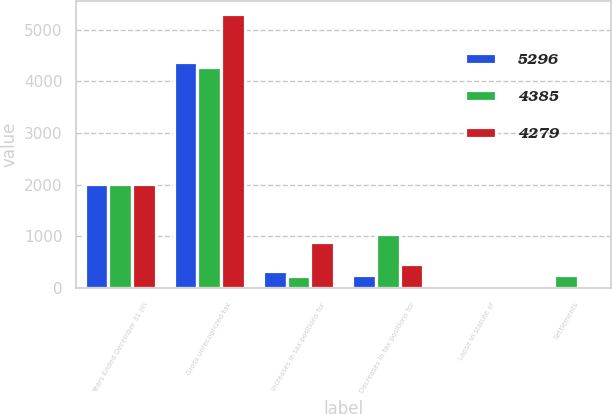Convert chart to OTSL. <chart><loc_0><loc_0><loc_500><loc_500><stacked_bar_chart><ecel><fcel>Years Ended December 31 (in<fcel>Gross unrecognized tax<fcel>Increases in tax positions for<fcel>Decreases in tax positions for<fcel>Lapse in statute of<fcel>Settlements<nl><fcel>5296<fcel>2012<fcel>4385<fcel>322<fcel>253<fcel>8<fcel>5<nl><fcel>4385<fcel>2011<fcel>4279<fcel>239<fcel>1046<fcel>7<fcel>259<nl><fcel>4279<fcel>2010<fcel>5296<fcel>888<fcel>470<fcel>6<fcel>12<nl></chart> 